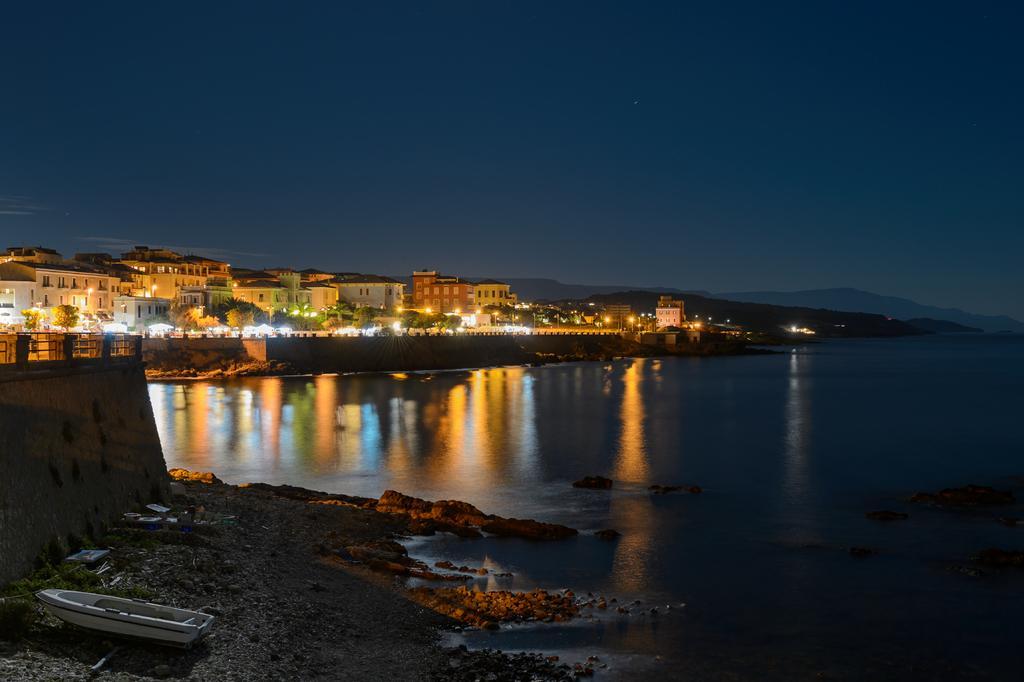Describe this image in one or two sentences. As we can see in the image there is water, boat, lights, trees and buildings. At the top there is sky. 